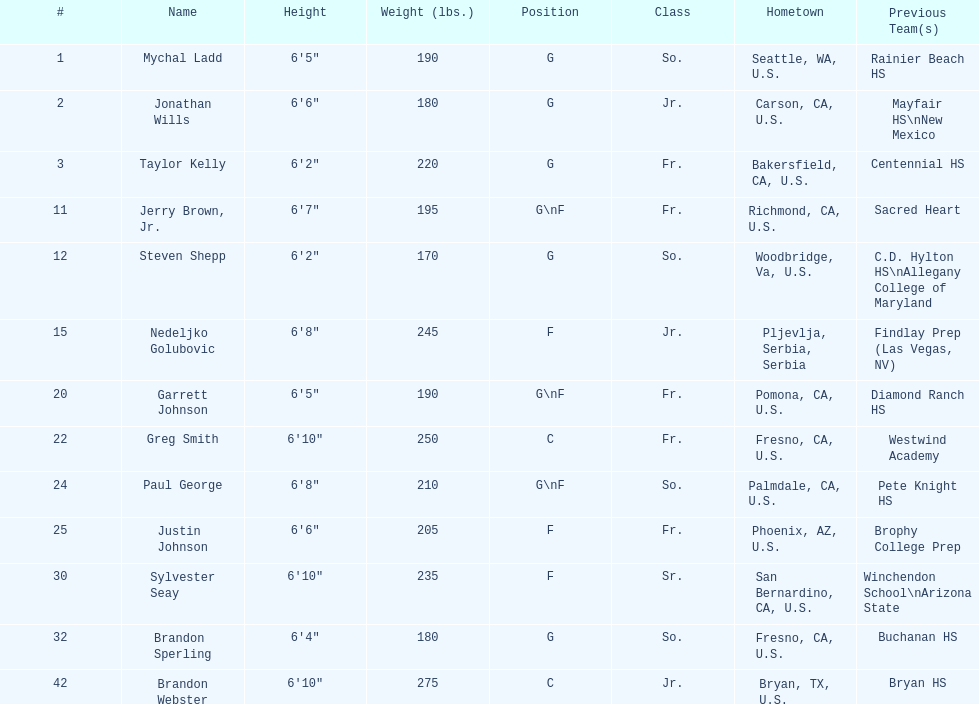Who is the exclusive participant not from the u.s.? Nedeljko Golubovic. 